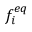<formula> <loc_0><loc_0><loc_500><loc_500>f _ { i } ^ { e q }</formula> 